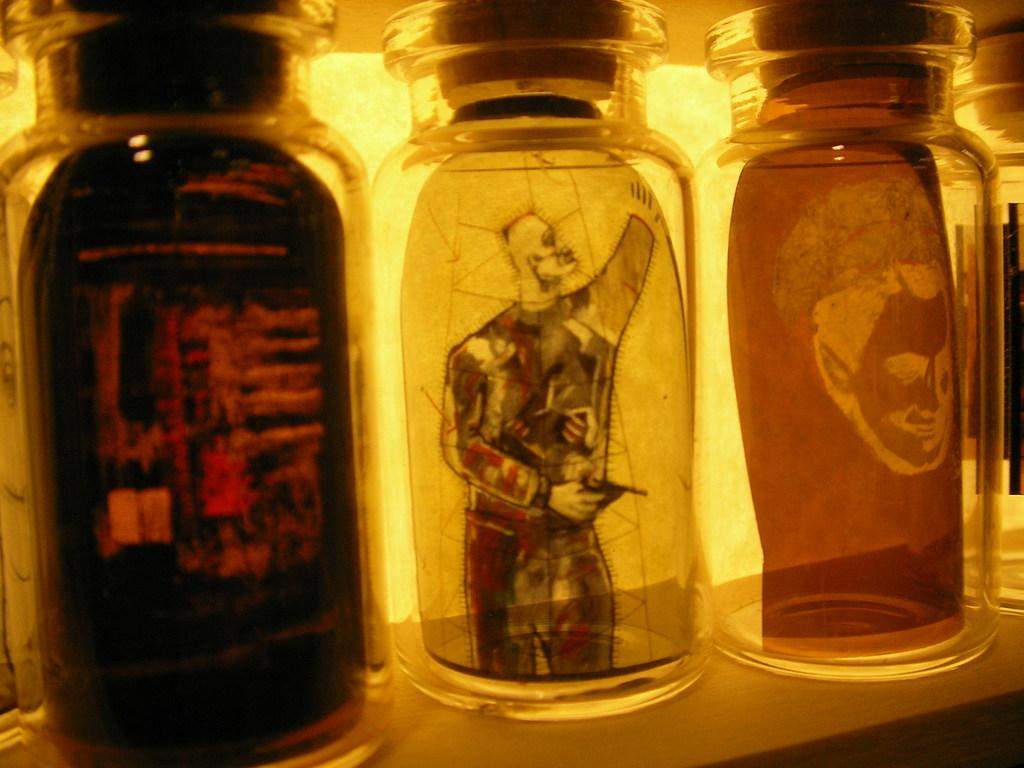How many jars are on the table in the image? There are three jars on the table in the image. What is inside the jars? There are paintings inside the jars. What type of corn can be seen growing on the slope in the image? There is no corn or slope present in the image; it features three jars with paintings inside. 